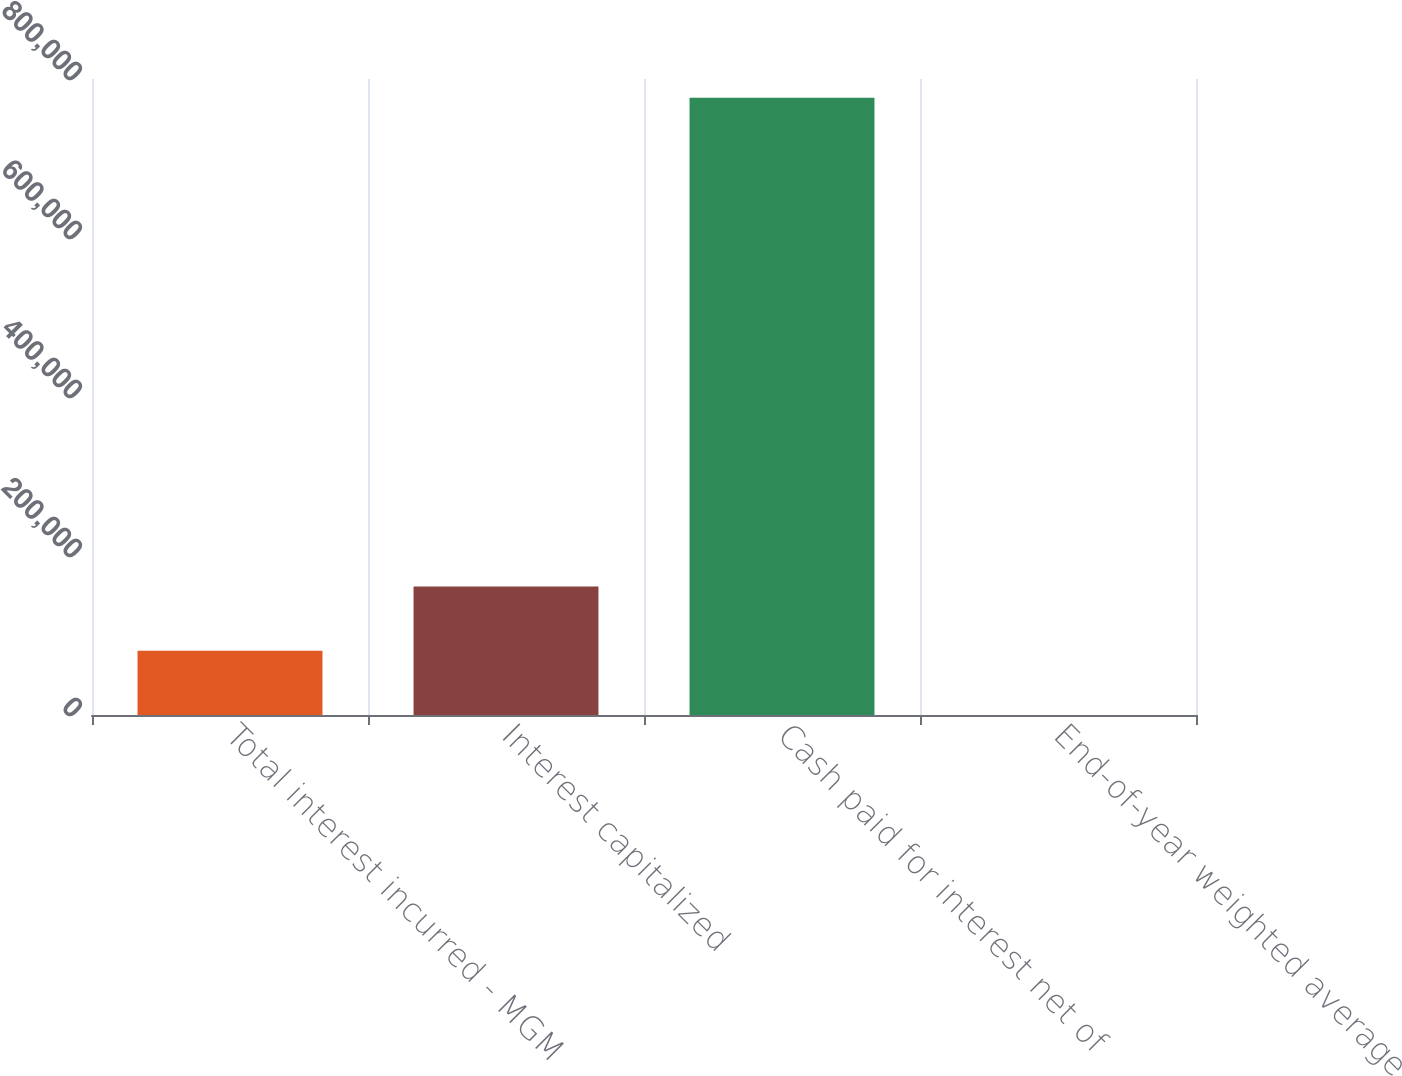Convert chart. <chart><loc_0><loc_0><loc_500><loc_500><bar_chart><fcel>Total interest incurred - MGM<fcel>Interest capitalized<fcel>Cash paid for interest net of<fcel>End-of-year weighted average<nl><fcel>80878.6<fcel>161751<fcel>776540<fcel>5.9<nl></chart> 